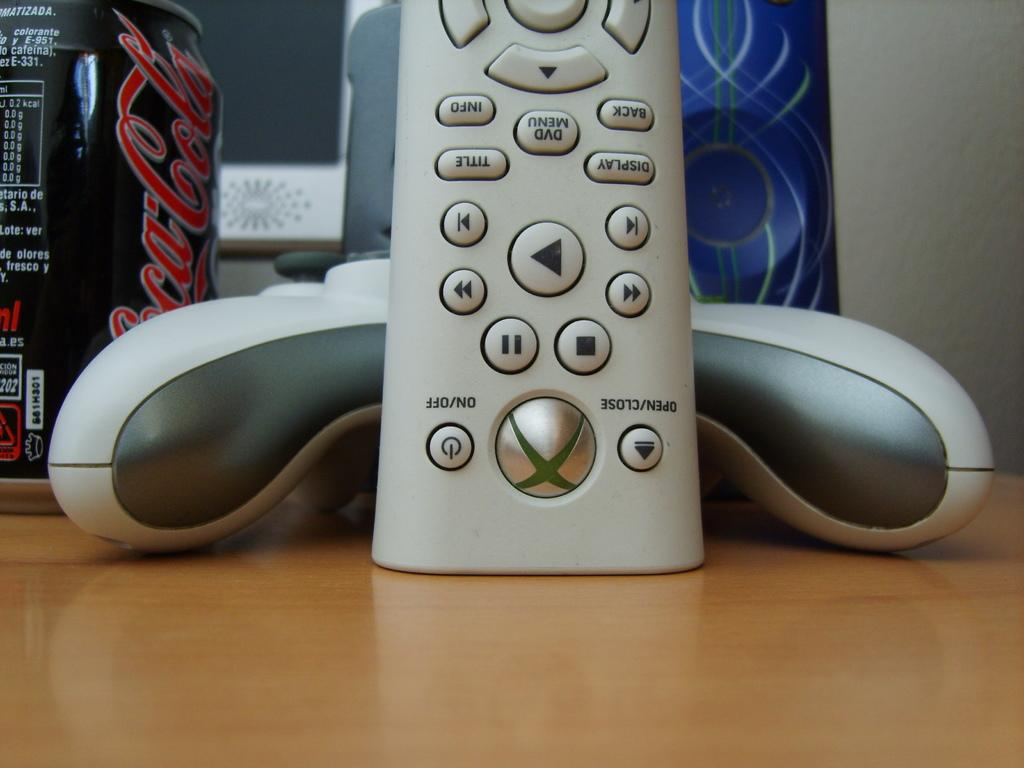<image>
Offer a succinct explanation of the picture presented. An Xbox remore control rests against a game controller with a coca cola can next to it. 